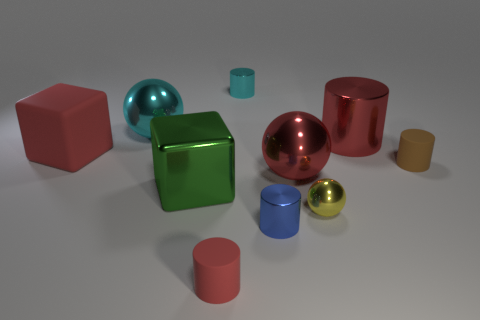There is a big green shiny thing; does it have the same shape as the big red object that is left of the big cyan metallic ball?
Provide a short and direct response. Yes. What is the small brown thing made of?
Provide a short and direct response. Rubber. What is the color of the large block behind the small matte thing on the right side of the red cylinder that is on the right side of the small yellow ball?
Give a very brief answer. Red. What material is the blue thing that is the same shape as the small cyan metallic object?
Provide a succinct answer. Metal. How many brown cylinders are the same size as the metal block?
Give a very brief answer. 0. How many gray rubber spheres are there?
Your answer should be compact. 0. Are the yellow ball and the big cube that is behind the large green shiny object made of the same material?
Your answer should be very brief. No. What number of brown objects are either tiny rubber cylinders or metallic blocks?
Your answer should be compact. 1. What size is the other cyan cylinder that is the same material as the large cylinder?
Provide a succinct answer. Small. What number of tiny cyan metallic objects have the same shape as the brown matte thing?
Give a very brief answer. 1. 